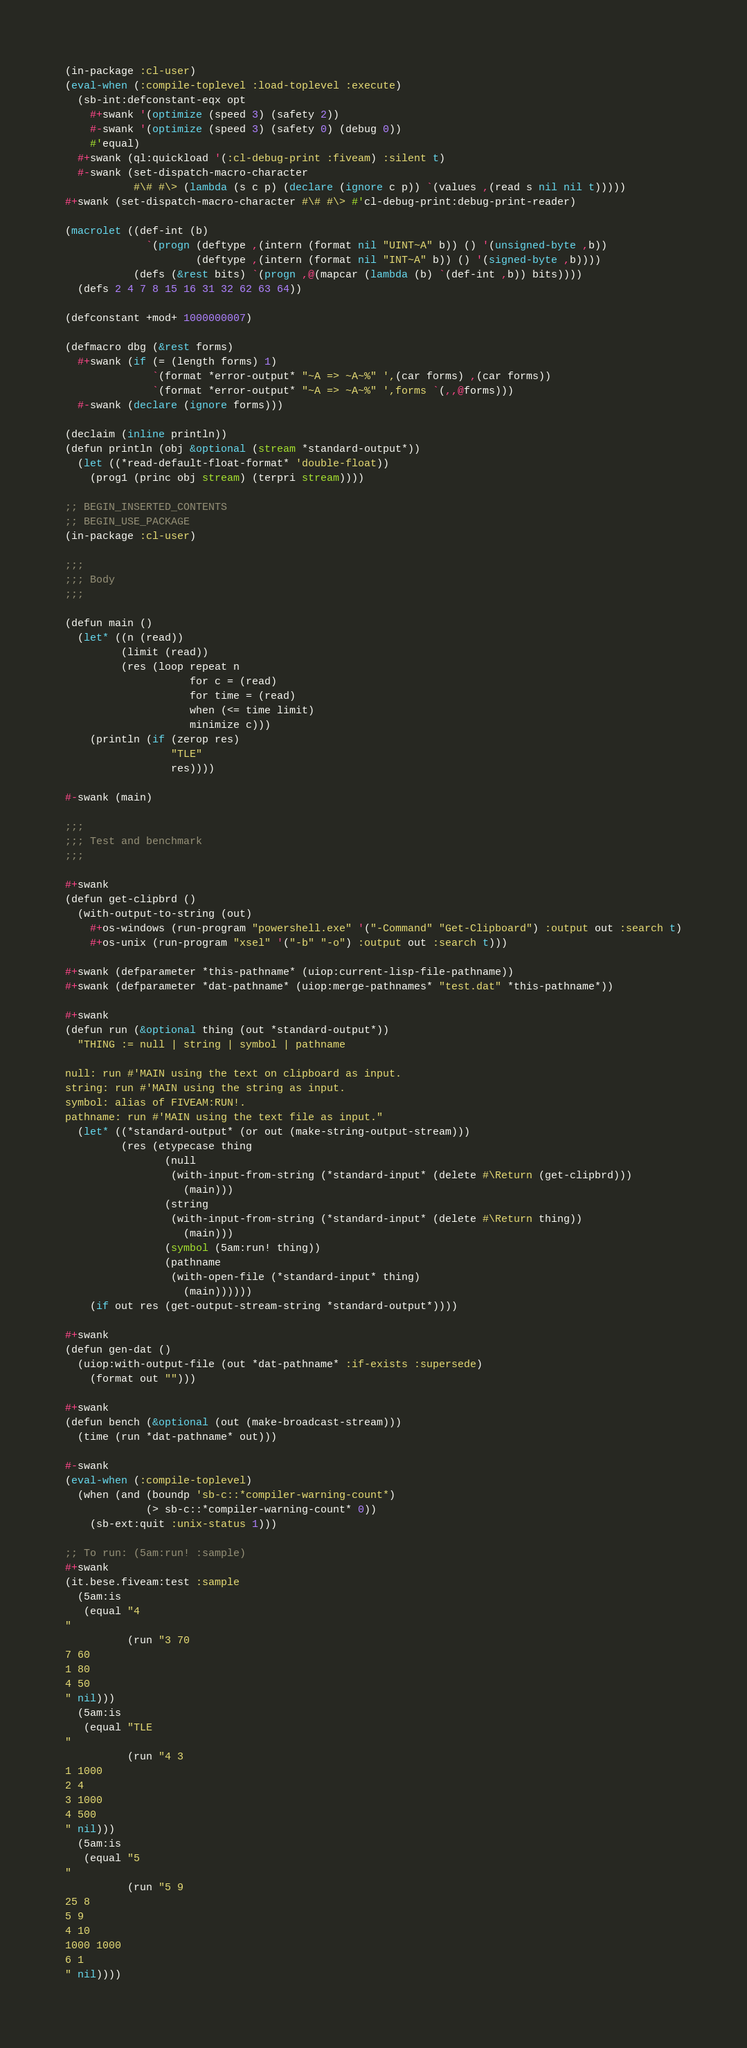<code> <loc_0><loc_0><loc_500><loc_500><_Lisp_>(in-package :cl-user)
(eval-when (:compile-toplevel :load-toplevel :execute)
  (sb-int:defconstant-eqx opt
    #+swank '(optimize (speed 3) (safety 2))
    #-swank '(optimize (speed 3) (safety 0) (debug 0))
    #'equal)
  #+swank (ql:quickload '(:cl-debug-print :fiveam) :silent t)
  #-swank (set-dispatch-macro-character
           #\# #\> (lambda (s c p) (declare (ignore c p)) `(values ,(read s nil nil t)))))
#+swank (set-dispatch-macro-character #\# #\> #'cl-debug-print:debug-print-reader)

(macrolet ((def-int (b)
             `(progn (deftype ,(intern (format nil "UINT~A" b)) () '(unsigned-byte ,b))
                     (deftype ,(intern (format nil "INT~A" b)) () '(signed-byte ,b))))
           (defs (&rest bits) `(progn ,@(mapcar (lambda (b) `(def-int ,b)) bits))))
  (defs 2 4 7 8 15 16 31 32 62 63 64))

(defconstant +mod+ 1000000007)

(defmacro dbg (&rest forms)
  #+swank (if (= (length forms) 1)
              `(format *error-output* "~A => ~A~%" ',(car forms) ,(car forms))
              `(format *error-output* "~A => ~A~%" ',forms `(,,@forms)))
  #-swank (declare (ignore forms)))

(declaim (inline println))
(defun println (obj &optional (stream *standard-output*))
  (let ((*read-default-float-format* 'double-float))
    (prog1 (princ obj stream) (terpri stream))))

;; BEGIN_INSERTED_CONTENTS
;; BEGIN_USE_PACKAGE
(in-package :cl-user)

;;;
;;; Body
;;;

(defun main ()
  (let* ((n (read))
         (limit (read))
         (res (loop repeat n
                    for c = (read)
                    for time = (read)
                    when (<= time limit)
                    minimize c)))
    (println (if (zerop res)
                 "TLE"
                 res))))

#-swank (main)

;;;
;;; Test and benchmark
;;;

#+swank
(defun get-clipbrd ()
  (with-output-to-string (out)
    #+os-windows (run-program "powershell.exe" '("-Command" "Get-Clipboard") :output out :search t)
    #+os-unix (run-program "xsel" '("-b" "-o") :output out :search t)))

#+swank (defparameter *this-pathname* (uiop:current-lisp-file-pathname))
#+swank (defparameter *dat-pathname* (uiop:merge-pathnames* "test.dat" *this-pathname*))

#+swank
(defun run (&optional thing (out *standard-output*))
  "THING := null | string | symbol | pathname

null: run #'MAIN using the text on clipboard as input.
string: run #'MAIN using the string as input.
symbol: alias of FIVEAM:RUN!.
pathname: run #'MAIN using the text file as input."
  (let* ((*standard-output* (or out (make-string-output-stream)))
         (res (etypecase thing
                (null
                 (with-input-from-string (*standard-input* (delete #\Return (get-clipbrd)))
                   (main)))
                (string
                 (with-input-from-string (*standard-input* (delete #\Return thing))
                   (main)))
                (symbol (5am:run! thing))
                (pathname
                 (with-open-file (*standard-input* thing)
                   (main))))))
    (if out res (get-output-stream-string *standard-output*))))

#+swank
(defun gen-dat ()
  (uiop:with-output-file (out *dat-pathname* :if-exists :supersede)
    (format out "")))

#+swank
(defun bench (&optional (out (make-broadcast-stream)))
  (time (run *dat-pathname* out)))

#-swank
(eval-when (:compile-toplevel)
  (when (and (boundp 'sb-c::*compiler-warning-count*)
             (> sb-c::*compiler-warning-count* 0))
    (sb-ext:quit :unix-status 1)))

;; To run: (5am:run! :sample)
#+swank
(it.bese.fiveam:test :sample
  (5am:is
   (equal "4
"
          (run "3 70
7 60
1 80
4 50
" nil)))
  (5am:is
   (equal "TLE
"
          (run "4 3
1 1000
2 4
3 1000
4 500
" nil)))
  (5am:is
   (equal "5
"
          (run "5 9
25 8
5 9
4 10
1000 1000
6 1
" nil))))
</code> 